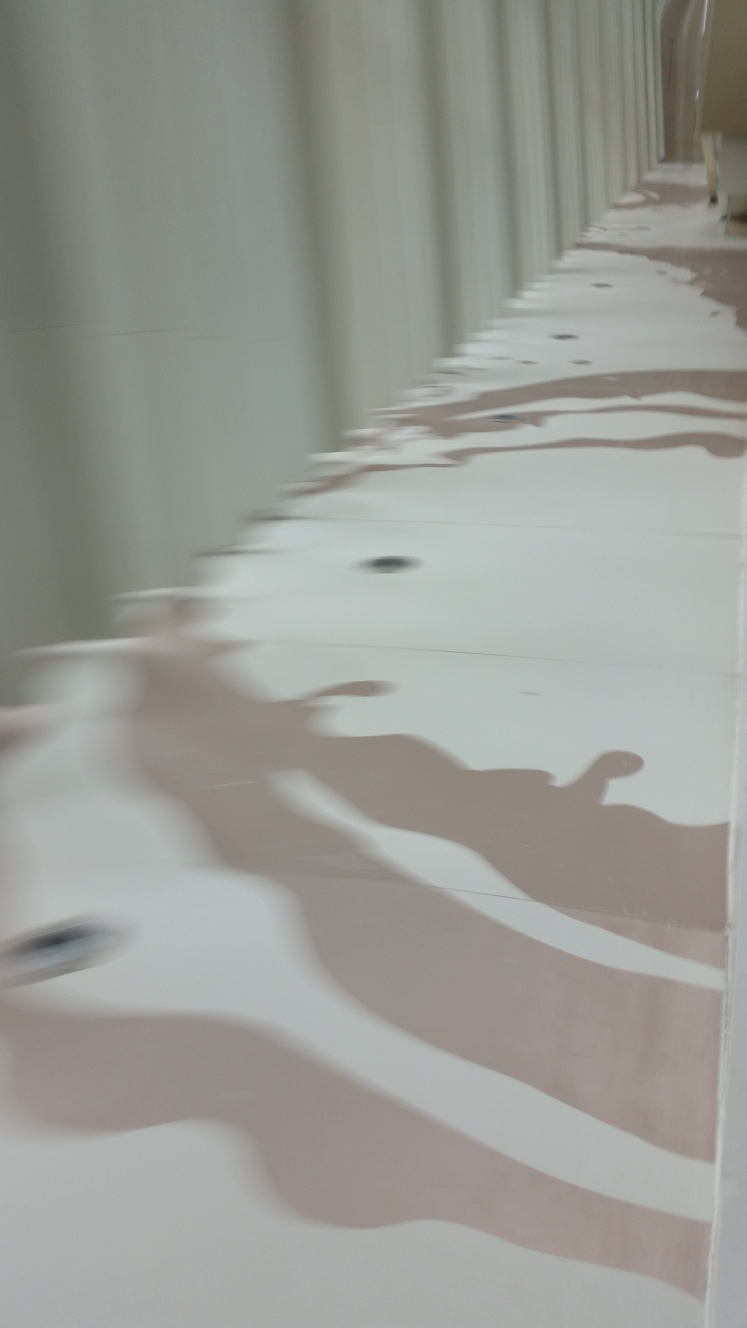Are there any quality issues with this image? The image appears to be slightly out of focus, resulting in a lack of sharpness. The motion blur effect, whether intentional or accidental, suggests movement or an unsteady camera. Additionally, the lighting seems uneven, possibly due to reflections, which affects the clarity of the image. 